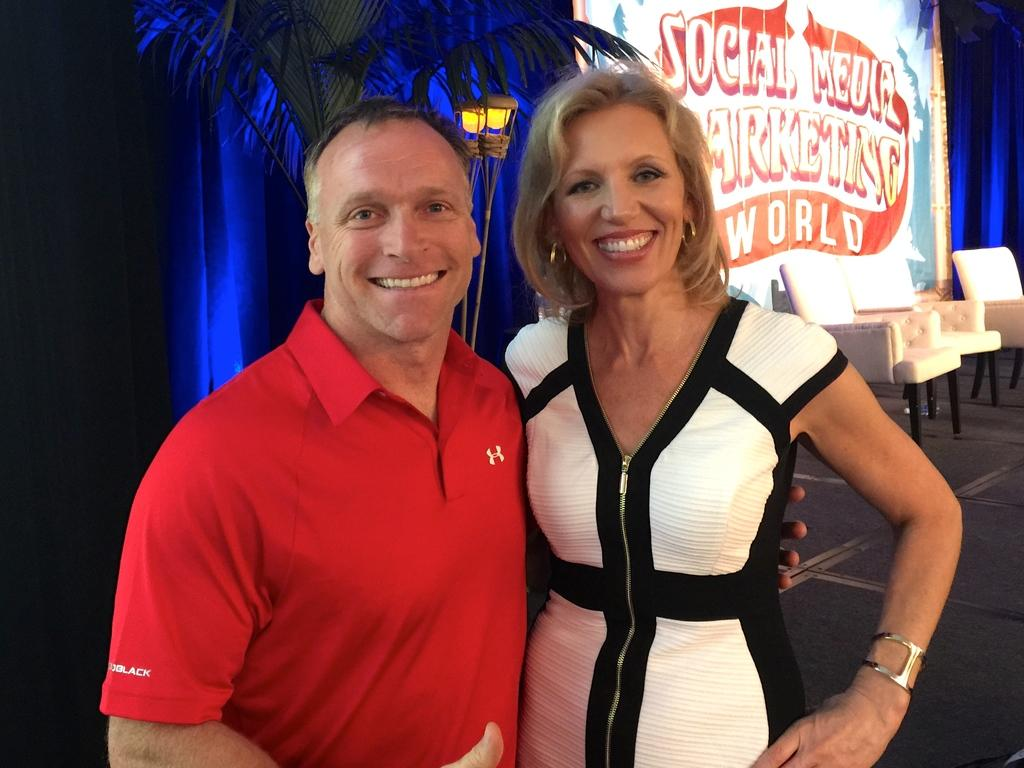Provide a one-sentence caption for the provided image. a social media marketing sign behind a couple. 